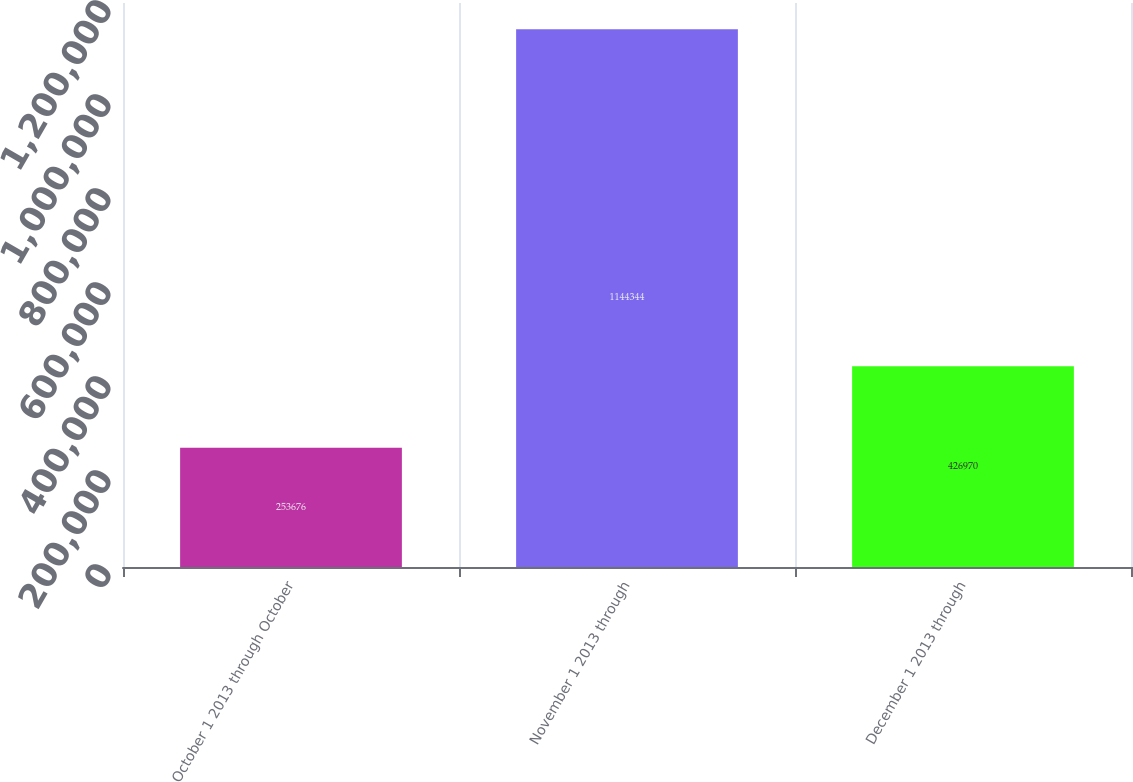<chart> <loc_0><loc_0><loc_500><loc_500><bar_chart><fcel>October 1 2013 through October<fcel>November 1 2013 through<fcel>December 1 2013 through<nl><fcel>253676<fcel>1.14434e+06<fcel>426970<nl></chart> 